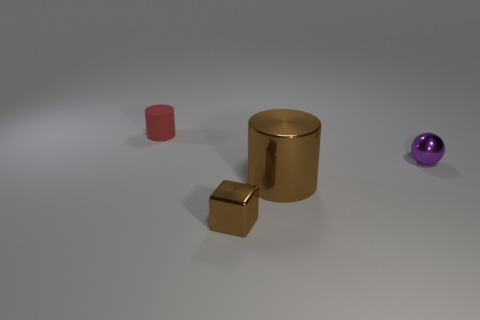Add 1 tiny blue metallic objects. How many objects exist? 5 Subtract all balls. How many objects are left? 3 Subtract all large brown metallic things. Subtract all brown metal things. How many objects are left? 1 Add 3 tiny purple shiny balls. How many tiny purple shiny balls are left? 4 Add 3 big blue matte cylinders. How many big blue matte cylinders exist? 3 Subtract 0 brown balls. How many objects are left? 4 